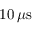<formula> <loc_0><loc_0><loc_500><loc_500>1 0 \, \mu s</formula> 